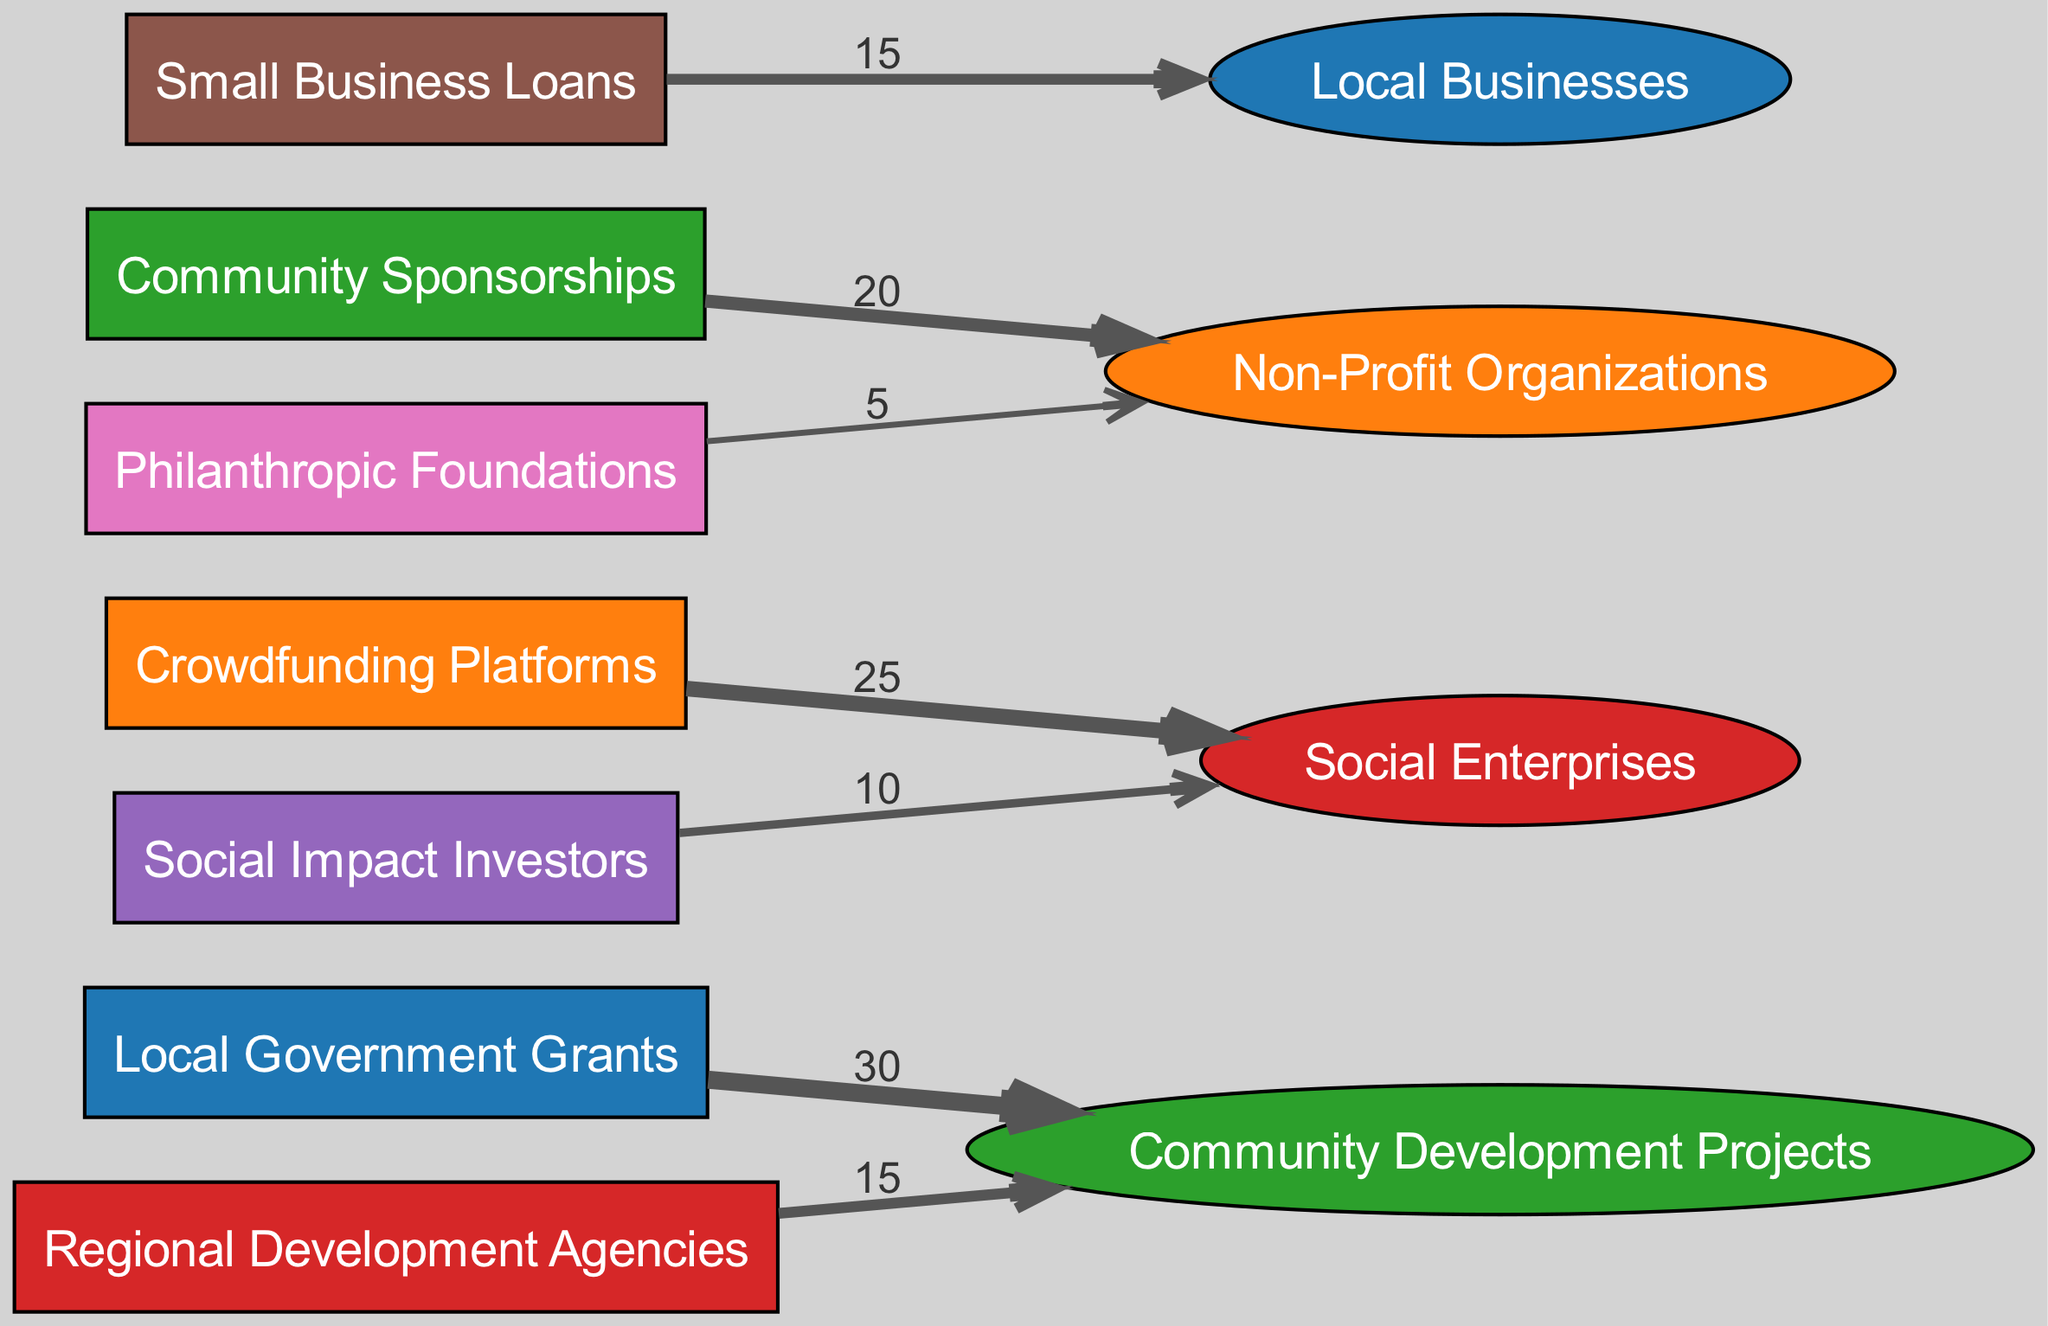What is the total value of funding from Local Government Grants? The diagram indicates that Local Government Grants flow to Community Development Projects with a value of 30. This is the only outgoing connection from this source, so the total value is directly 30.
Answer: 30 Which source has the highest contribution to Social Enterprises? According to the diagram, Crowdfunding Platforms provide a contribution of 25 to Social Enterprises, which is the highest compared to the other sources that connect to this node.
Answer: Crowdfunding Platforms How many total funding sources are depicted in the diagram? The diagram lists 7 distinct funding sources (Local Government Grants, Crowdfunding Platforms, Community Sponsorships, Regional Development Agencies, Social Impact Investors, Small Business Loans, Philanthropic Foundations). Counting these gives a total of 7 sources.
Answer: 7 Which sink receives funding from both Community Sponsorships and Philanthropic Foundations? The diagram shows that both Community Sponsorships and Philanthropic Foundations direct funding to Non-Profit Organizations. Therefore, the sink that receives contributions from both is Non-Profit Organizations.
Answer: Non-Profit Organizations What is the combined funding value to Community Development Projects? The diagram reveals that Community Development Projects receive funding from Local Government Grants (30) and Regional Development Agencies (15). Adding these two contributions gives a total of 45 to Community Development Projects (30 + 15 = 45).
Answer: 45 Which funding source has the lowest contribution and what is its value? Upon examining the diagram, Philanthropic Foundations contribute the least to Non-Profit Organizations with a value of 5, which is lower than all other source contributions.
Answer: 5 Which sink has the maximum total funding from all sources combined? By reviewing the contributions, Social Enterprises receive funding from Crowdfunding Platforms (25) and Social Impact Investors (10), totaling 35. In comparison, Non-Profit Organizations receive 20 from Community Sponsorships and 5 from Philanthropic Foundations, totaling 25. Therefore, Social Enterprises have the maximum total funding of 35.
Answer: Social Enterprises How many edges originate from Regional Development Agencies? The diagram shows that Regional Development Agencies have a single outgoing link to Community Development Projects, indicating that there is only one edge originating from this source.
Answer: 1 